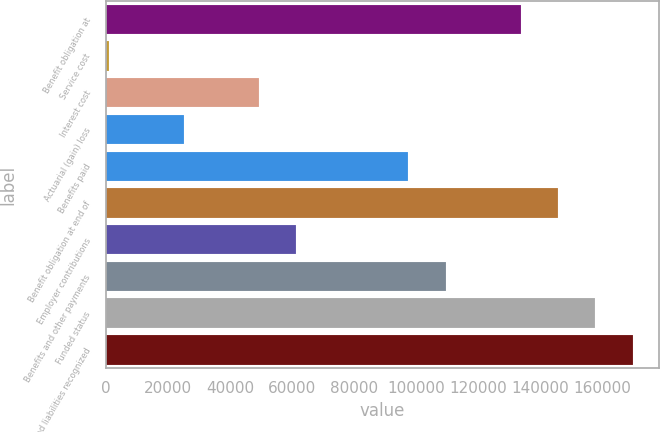<chart> <loc_0><loc_0><loc_500><loc_500><bar_chart><fcel>Benefit obligation at<fcel>Service cost<fcel>Interest cost<fcel>Actuarial (gain) loss<fcel>Benefits paid<fcel>Benefit obligation at end of<fcel>Employer contributions<fcel>Benefits and other payments<fcel>Funded status<fcel>Accrued liabilities recognized<nl><fcel>133555<fcel>914<fcel>49147.2<fcel>25030.6<fcel>97380.4<fcel>145614<fcel>61205.5<fcel>109439<fcel>157672<fcel>169730<nl></chart> 